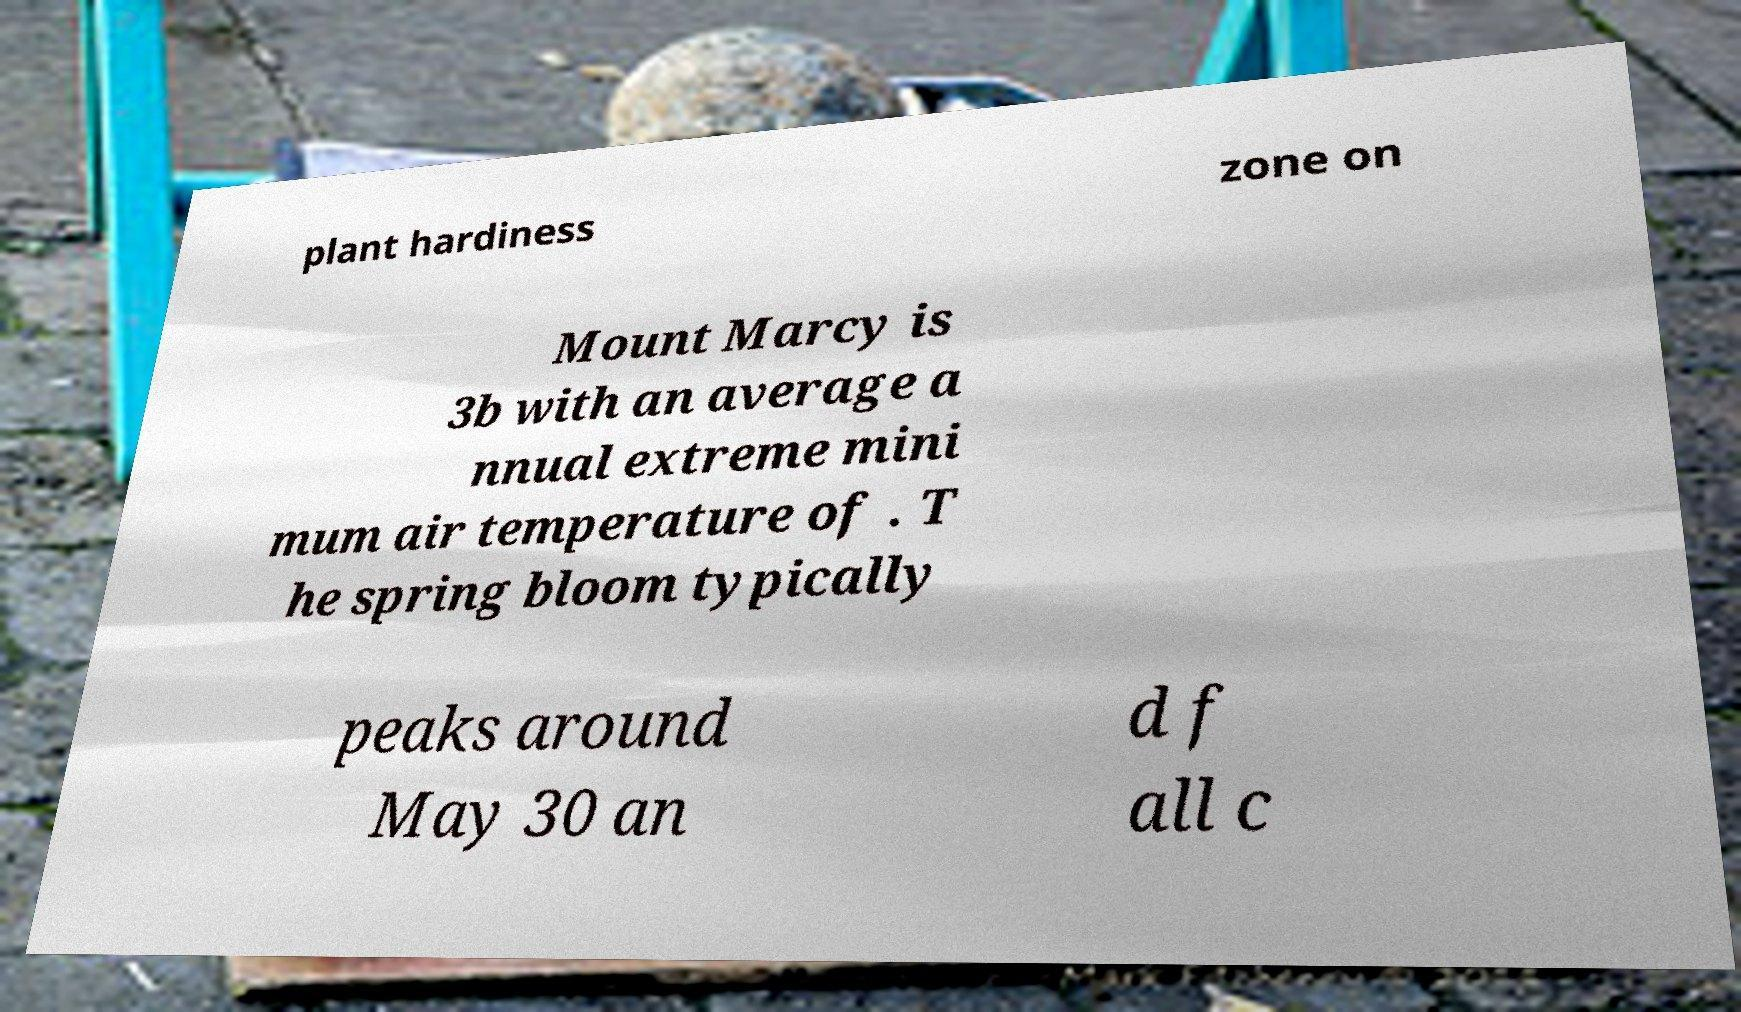Please identify and transcribe the text found in this image. plant hardiness zone on Mount Marcy is 3b with an average a nnual extreme mini mum air temperature of . T he spring bloom typically peaks around May 30 an d f all c 